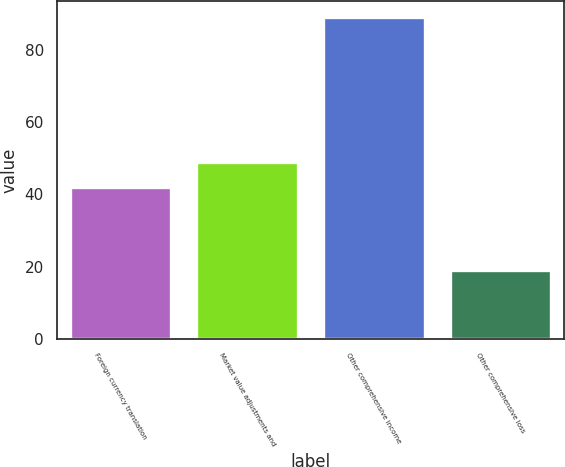Convert chart. <chart><loc_0><loc_0><loc_500><loc_500><bar_chart><fcel>Foreign currency translation<fcel>Market value adjustments and<fcel>Other comprehensive income<fcel>Other comprehensive loss<nl><fcel>42<fcel>49<fcel>89<fcel>19<nl></chart> 